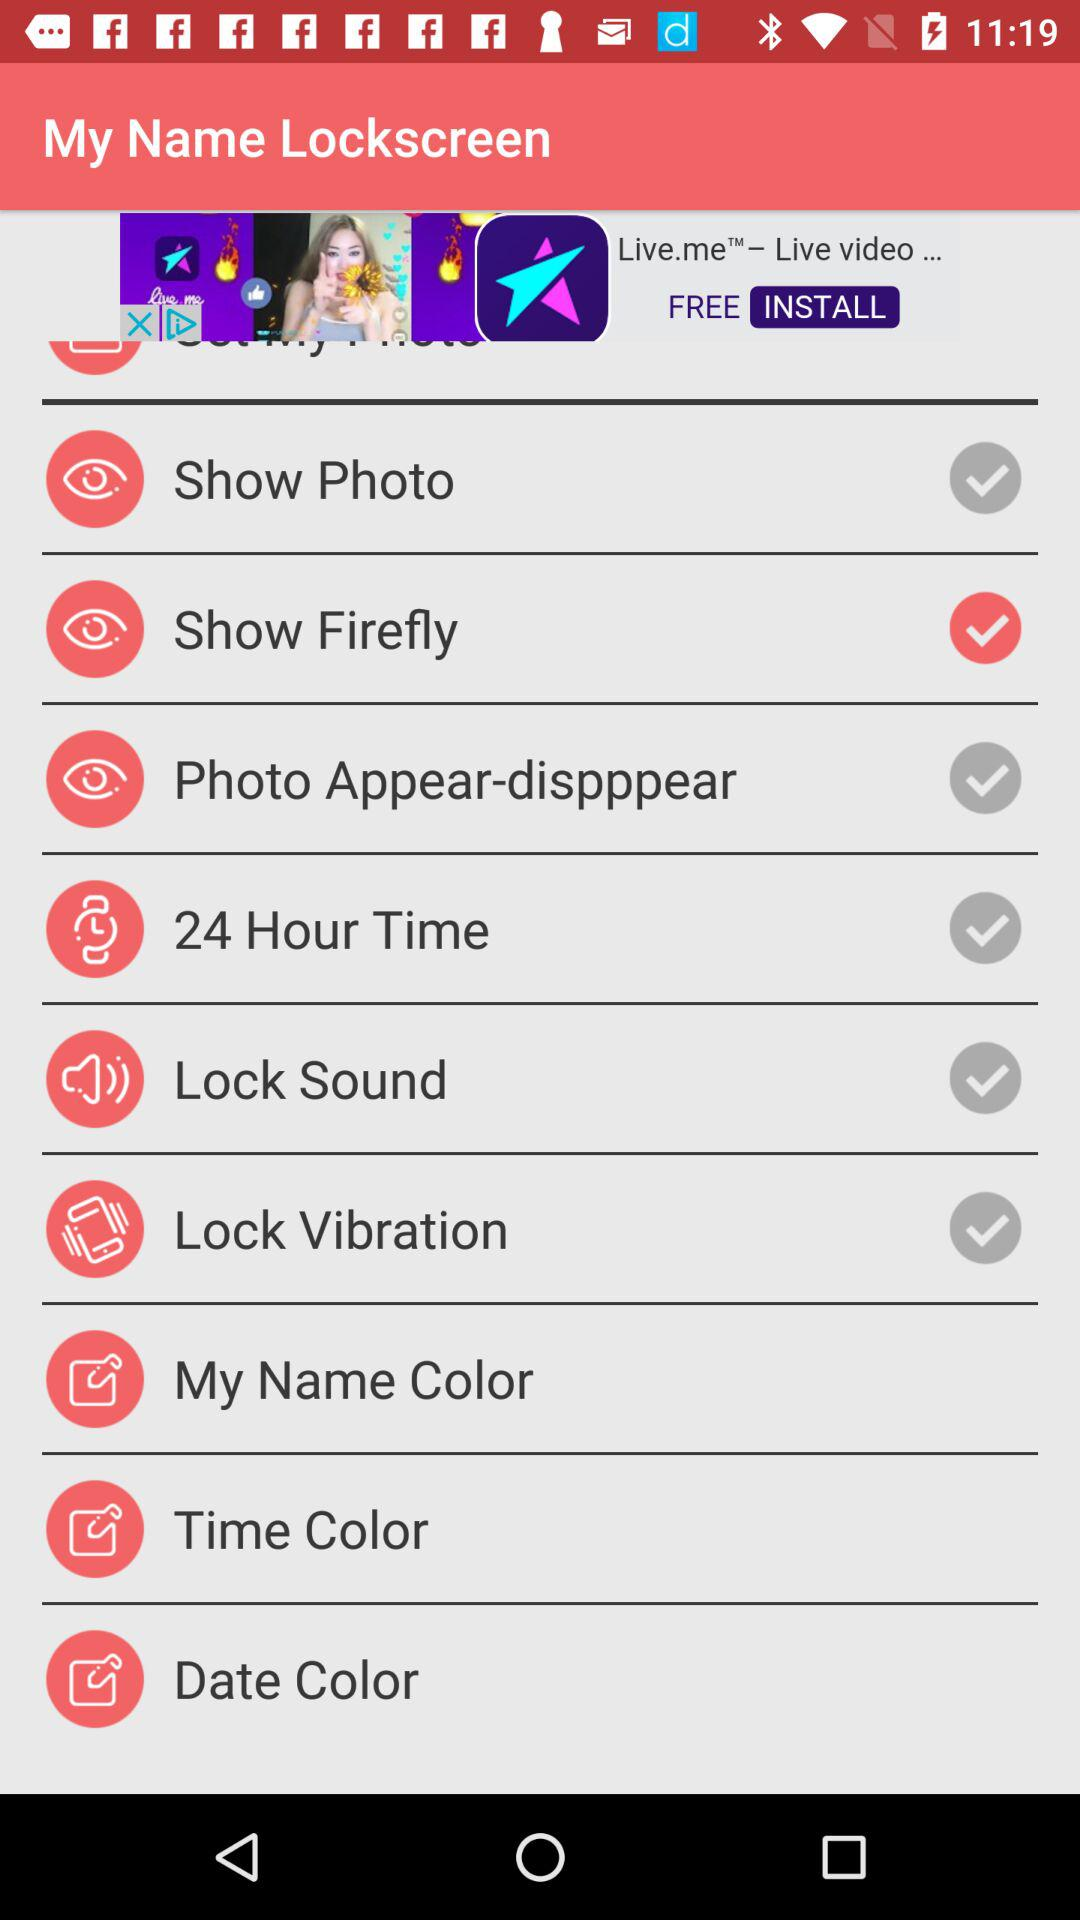What color is selected for "My Name Color"?
When the provided information is insufficient, respond with <no answer>. <no answer> 